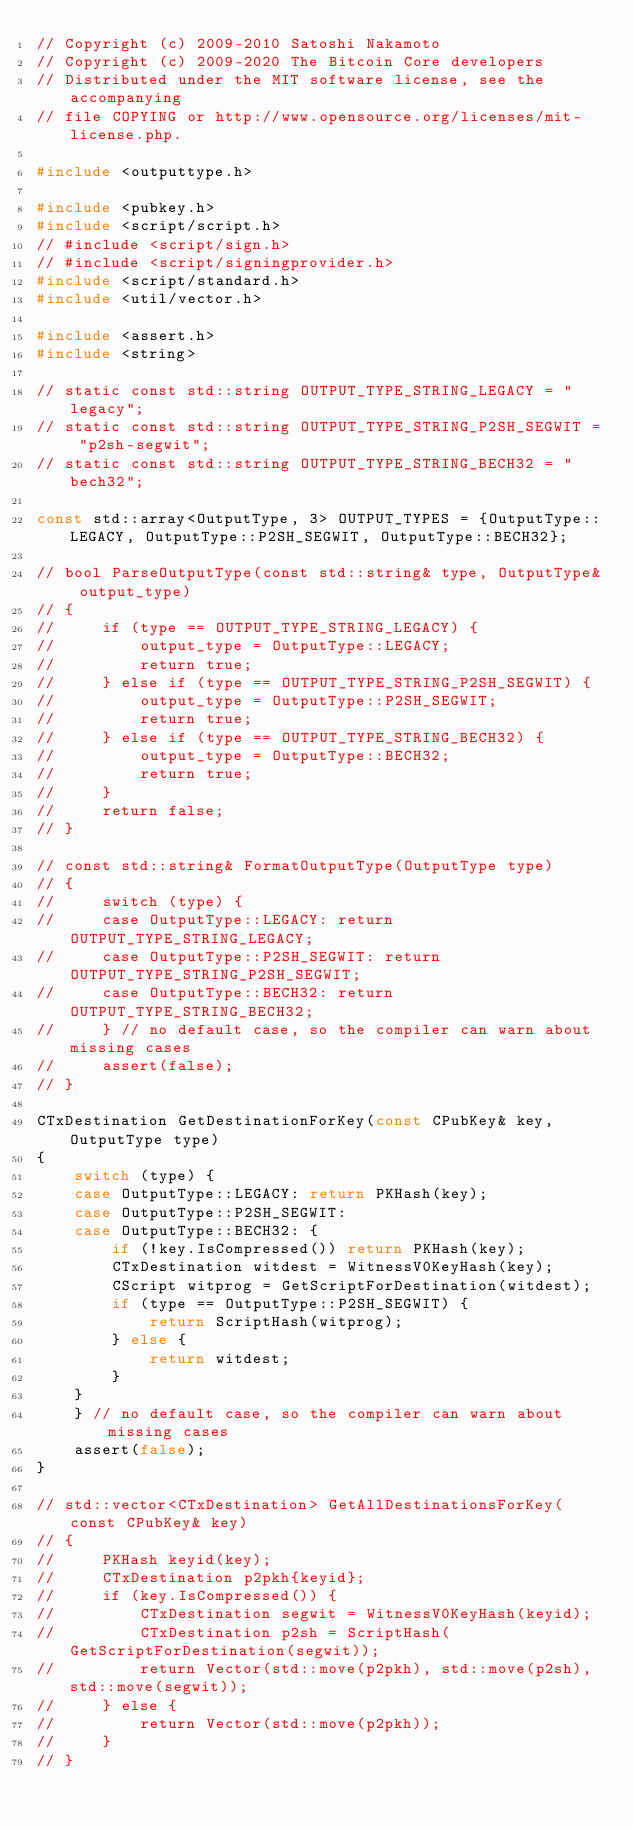Convert code to text. <code><loc_0><loc_0><loc_500><loc_500><_C++_>// Copyright (c) 2009-2010 Satoshi Nakamoto
// Copyright (c) 2009-2020 The Bitcoin Core developers
// Distributed under the MIT software license, see the accompanying
// file COPYING or http://www.opensource.org/licenses/mit-license.php.

#include <outputtype.h>

#include <pubkey.h>
#include <script/script.h>
// #include <script/sign.h>
// #include <script/signingprovider.h>
#include <script/standard.h>
#include <util/vector.h>

#include <assert.h>
#include <string>

// static const std::string OUTPUT_TYPE_STRING_LEGACY = "legacy";
// static const std::string OUTPUT_TYPE_STRING_P2SH_SEGWIT = "p2sh-segwit";
// static const std::string OUTPUT_TYPE_STRING_BECH32 = "bech32";

const std::array<OutputType, 3> OUTPUT_TYPES = {OutputType::LEGACY, OutputType::P2SH_SEGWIT, OutputType::BECH32};

// bool ParseOutputType(const std::string& type, OutputType& output_type)
// {
//     if (type == OUTPUT_TYPE_STRING_LEGACY) {
//         output_type = OutputType::LEGACY;
//         return true;
//     } else if (type == OUTPUT_TYPE_STRING_P2SH_SEGWIT) {
//         output_type = OutputType::P2SH_SEGWIT;
//         return true;
//     } else if (type == OUTPUT_TYPE_STRING_BECH32) {
//         output_type = OutputType::BECH32;
//         return true;
//     }
//     return false;
// }

// const std::string& FormatOutputType(OutputType type)
// {
//     switch (type) {
//     case OutputType::LEGACY: return OUTPUT_TYPE_STRING_LEGACY;
//     case OutputType::P2SH_SEGWIT: return OUTPUT_TYPE_STRING_P2SH_SEGWIT;
//     case OutputType::BECH32: return OUTPUT_TYPE_STRING_BECH32;
//     } // no default case, so the compiler can warn about missing cases
//     assert(false);
// }
 
CTxDestination GetDestinationForKey(const CPubKey& key, OutputType type)
{
    switch (type) {
    case OutputType::LEGACY: return PKHash(key);
    case OutputType::P2SH_SEGWIT:
    case OutputType::BECH32: {
        if (!key.IsCompressed()) return PKHash(key);
        CTxDestination witdest = WitnessV0KeyHash(key);
        CScript witprog = GetScriptForDestination(witdest);
        if (type == OutputType::P2SH_SEGWIT) {
            return ScriptHash(witprog);
        } else {
            return witdest;
        }
    }
    } // no default case, so the compiler can warn about missing cases
    assert(false);
}

// std::vector<CTxDestination> GetAllDestinationsForKey(const CPubKey& key)
// {
//     PKHash keyid(key);
//     CTxDestination p2pkh{keyid};
//     if (key.IsCompressed()) {
//         CTxDestination segwit = WitnessV0KeyHash(keyid);
//         CTxDestination p2sh = ScriptHash(GetScriptForDestination(segwit));
//         return Vector(std::move(p2pkh), std::move(p2sh), std::move(segwit));
//     } else {
//         return Vector(std::move(p2pkh));
//     }
// }
</code> 